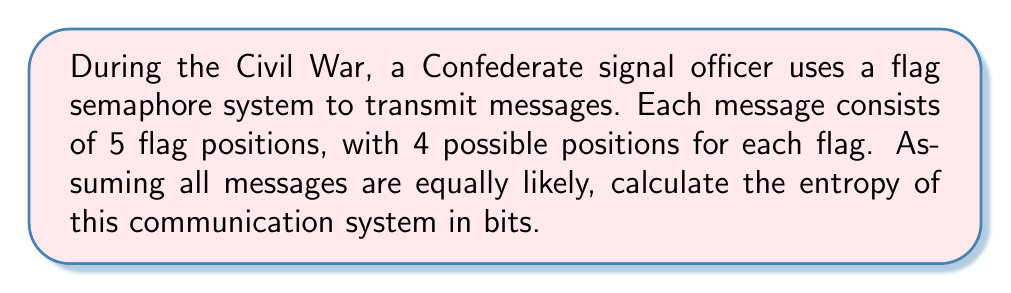Provide a solution to this math problem. To solve this problem, we'll follow these steps:

1. Determine the number of possible messages:
   With 4 possible positions for each flag and 5 flags per message, the total number of possible messages is:
   $$ N = 4^5 = 1024 $$

2. Calculate the probability of each message:
   Since all messages are equally likely, the probability of each message is:
   $$ p = \frac{1}{N} = \frac{1}{1024} $$

3. Apply the entropy formula:
   The entropy $H$ of a system with $N$ equally likely outcomes is given by:
   $$ H = -\sum_{i=1}^N p_i \log_2(p_i) $$
   
   Where $p_i$ is the probability of each outcome.

4. Simplify the calculation:
   Since all probabilities are equal, we can simplify:
   $$ H = -N \cdot p \log_2(p) $$
   $$ H = -1024 \cdot \frac{1}{1024} \log_2(\frac{1}{1024}) $$
   $$ H = -\log_2(\frac{1}{1024}) $$
   $$ H = \log_2(1024) $$

5. Compute the final result:
   $$ H = \log_2(2^{10}) = 10 \text{ bits} $$
Answer: 10 bits 